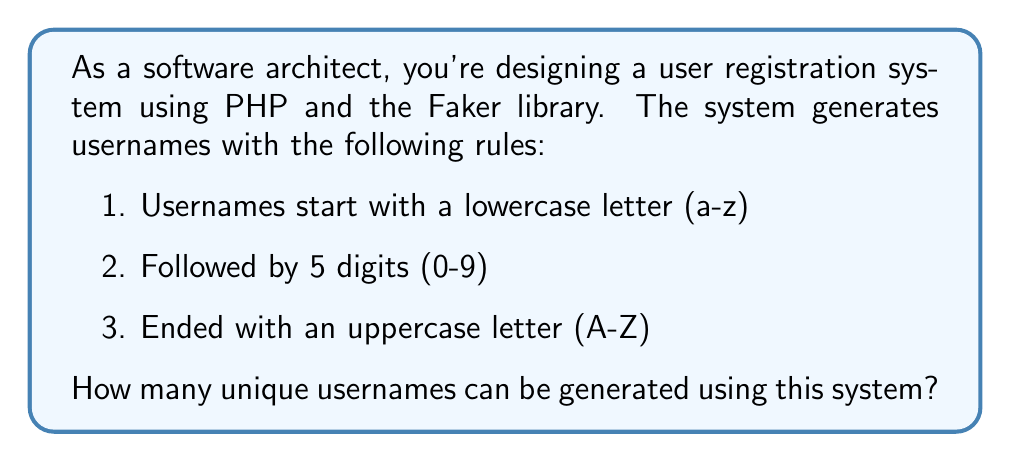Can you solve this math problem? Let's break this down step-by-step:

1. First letter (lowercase):
   There are 26 possible lowercase letters (a-z).
   $n_1 = 26$

2. Five digits:
   For each digit, we have 10 possibilities (0-9).
   We need to choose 5 digits, and the order matters.
   This is a case of repetition allowed.
   $n_2 = 10^5 = 100,000$

3. Last letter (uppercase):
   There are 26 possible uppercase letters (A-Z).
   $n_3 = 26$

4. Total number of combinations:
   We use the multiplication principle here. The total number of combinations is the product of the number of possibilities for each part.

   $\text{Total} = n_1 \times n_2 \times n_3$
   
   $\text{Total} = 26 \times 100,000 \times 26$
   
   $\text{Total} = 67,600,000$

Therefore, the number of unique usernames that can be generated is 67,600,000.
Answer: 67,600,000 